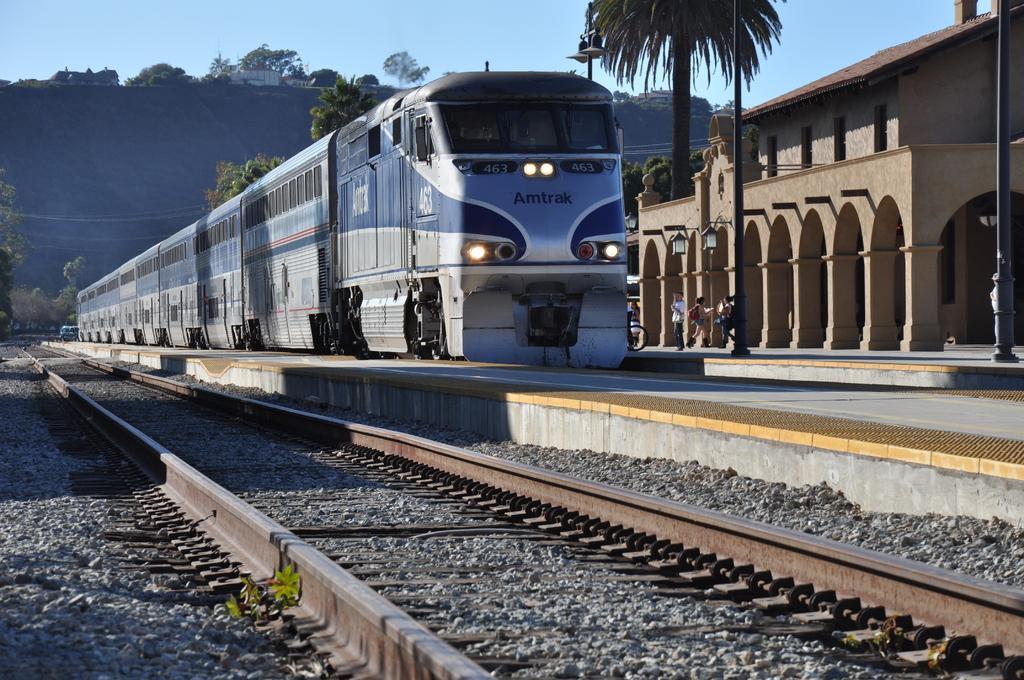Could you give a brief overview of what you see in this image? In this picture I can see the track in front and I can see number of stones. In the middle of this picture I can see the platforms, poles, a building, a train on which there are lights, numbers and a word written and I see few people. In the background I can see the trees, few buildings and the sky. 